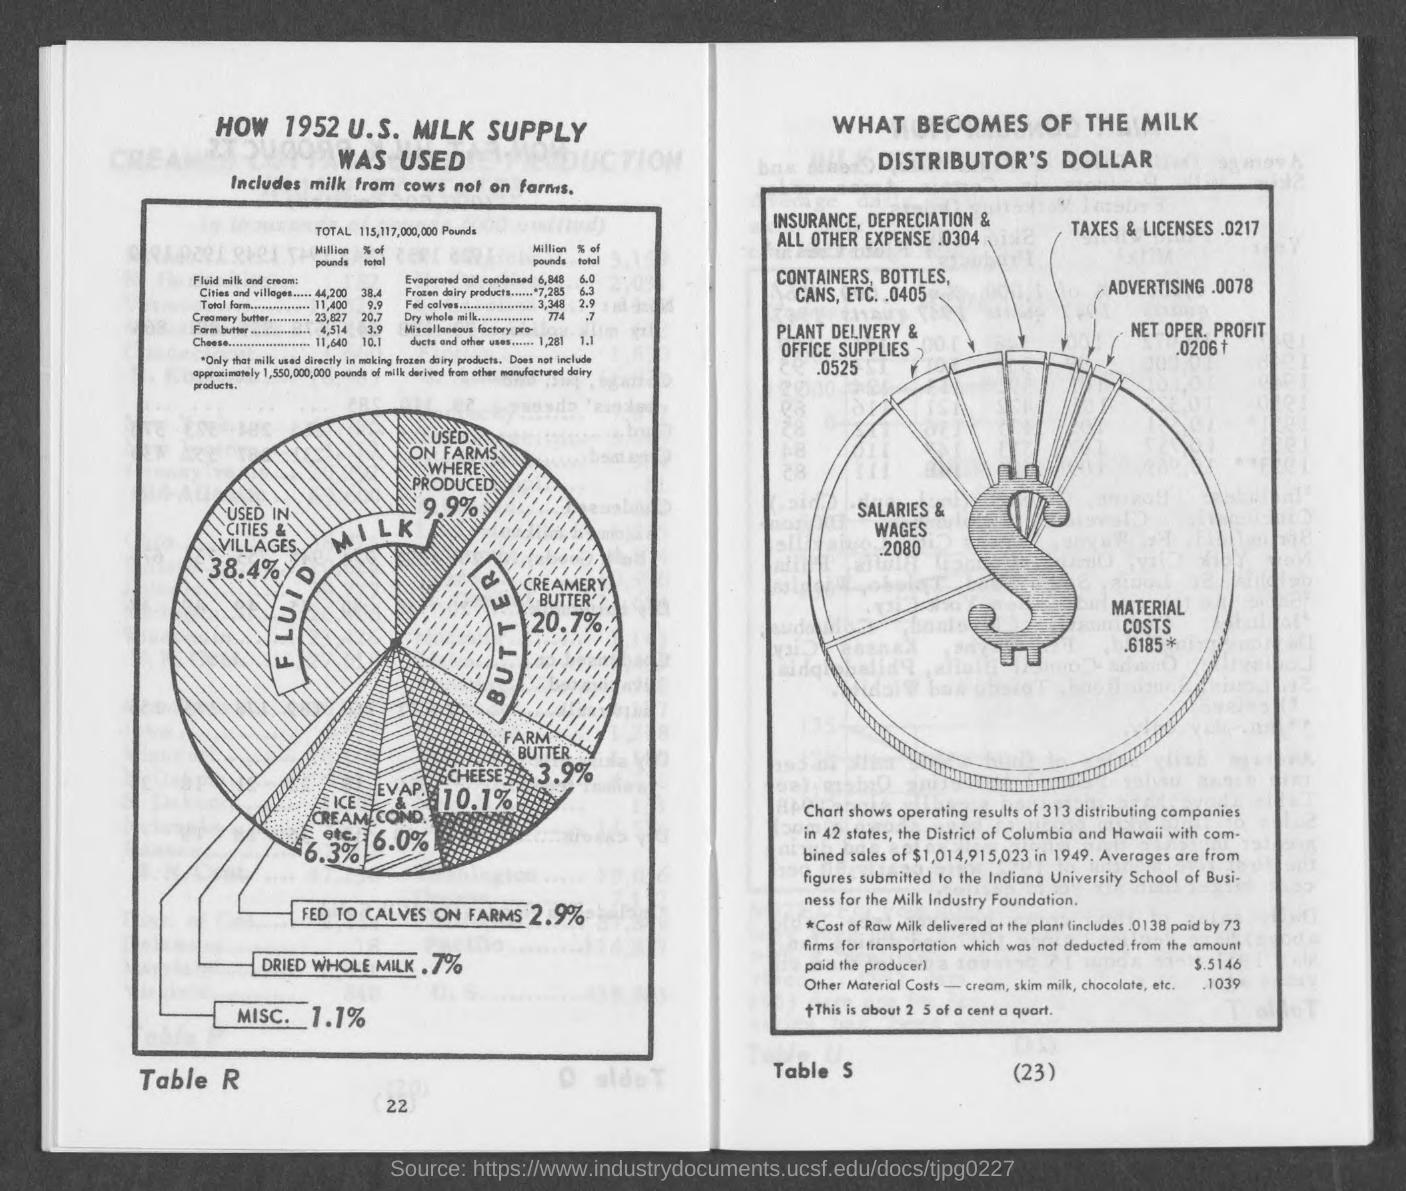What is the number below table r?
Make the answer very short. 22. What is the number below table s?
Offer a terse response. 23. 